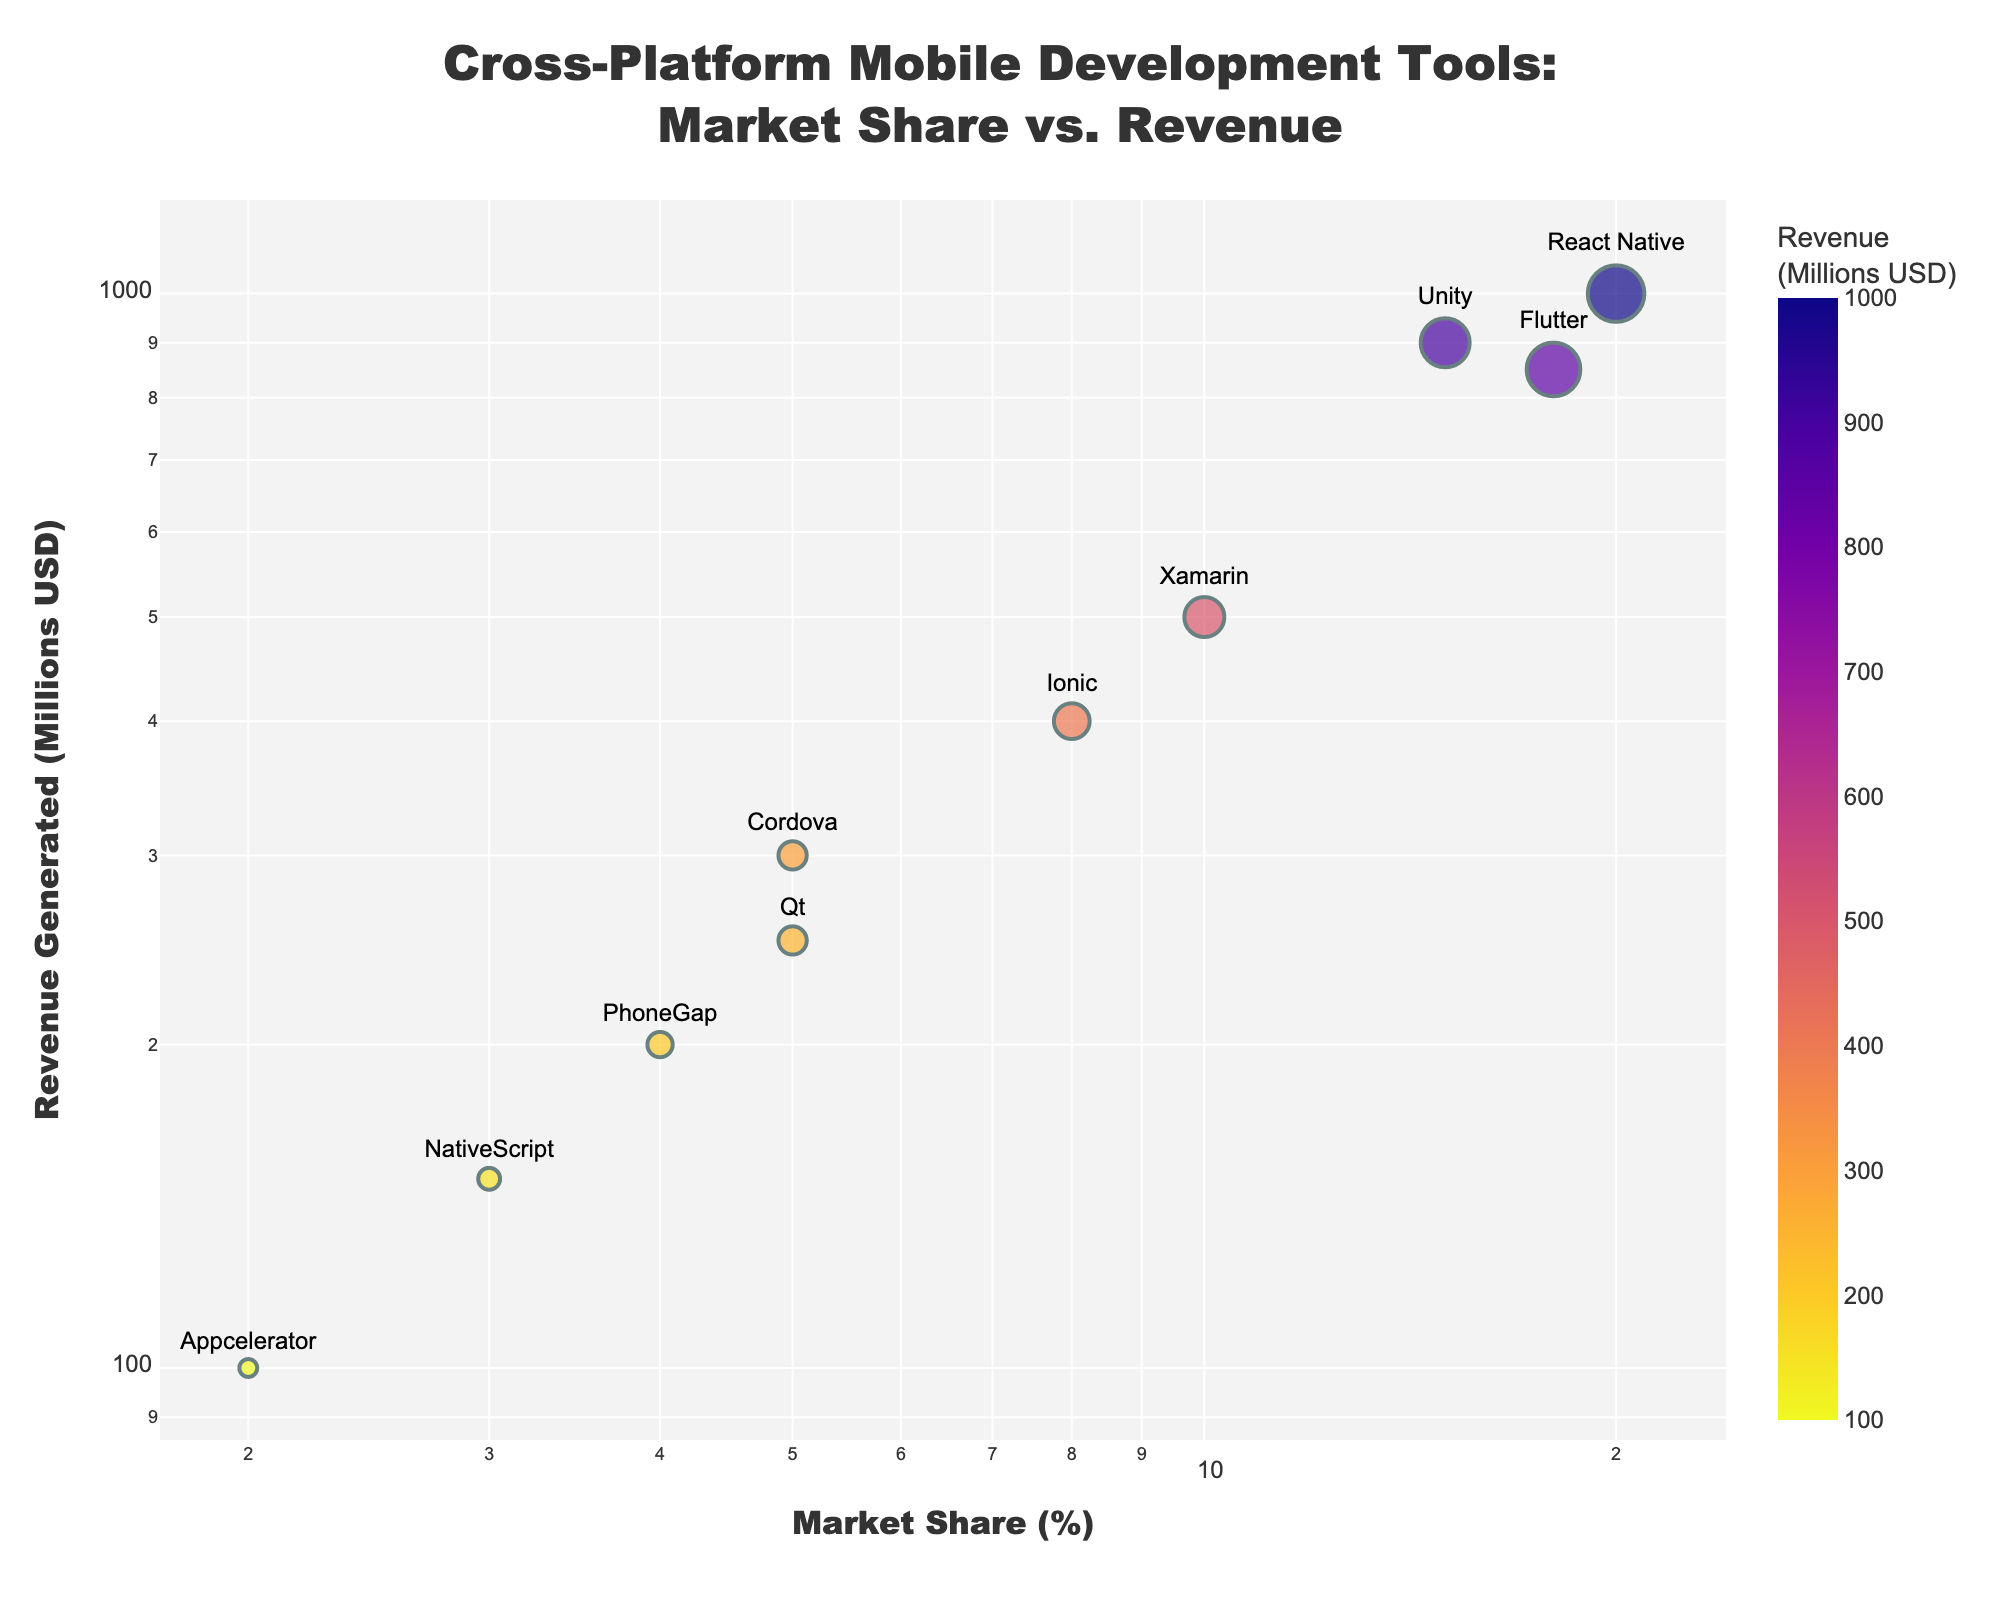What is the title of the scatter plot? The title is visible at the top of the scatter plot and reads: "Cross-Platform Mobile Development Tools: Market Share vs. Revenue"
Answer: Cross-Platform Mobile Development Tools: Market Share vs. Revenue Which tool has the highest market share in the plot? By checking the x-axis, the tool furthest to the right has the highest market share, which is React Native at 20%.
Answer: React Native What tool generated the highest revenue? By examining the y-axis, the tool positioned highest has generated the most revenue, which is React Native with $1000 million.
Answer: React Native How many tools have a market share of less than 5%? On the x-axis, identify the tools that fall under the 5% mark, which are Appcelerator, NativeScript, PhoneGap, and Cordova. Thus, there are 4 tools.
Answer: 4 What is the revenue difference between Unity and Xamarin? Unity generated $900 million while Xamarin generated $500 million. Calculating the difference: 900 - 500 = 400.
Answer: $400 million Which tool has the smallest market share and what is its revenue? From the x-axis, Appcelerator has the smallest market share at 2%. Its corresponding revenue, from the y-axis, is $100 million.
Answer: Appcelerator, $100 million Is there a direct correlation between market share and revenue generated among these tools? By visual inspection, tools with higher market share generally have higher revenues, suggesting a positive correlation between market share and revenue.
Answer: Yes Which tool, aside from React Native, has a market share greater than 15%? Checking the x-axis, Unity is another tool with a market share greater than 15%.
Answer: Unity What is the average revenue generated by tools with less than 10% market share? Tools with less than 10% market share are Ionic, Cordova, Appcelerator, NativeScript, PhoneGap, and Qt. Their revenues are 400 + 300 + 100 + 150 + 200 + 250 = $1,400 million. There are 6 tools, so the average revenue is 1,400 / 6 ≈ 233.33.
Answer: $233.33 million Which tool is closest in market share to Flutter, and what is its revenue? By locating Flutter's market share on the x-axis (18%), Unity is closest with 15% market share. Unity's revenue is $900 million.
Answer: Unity, $900 million 